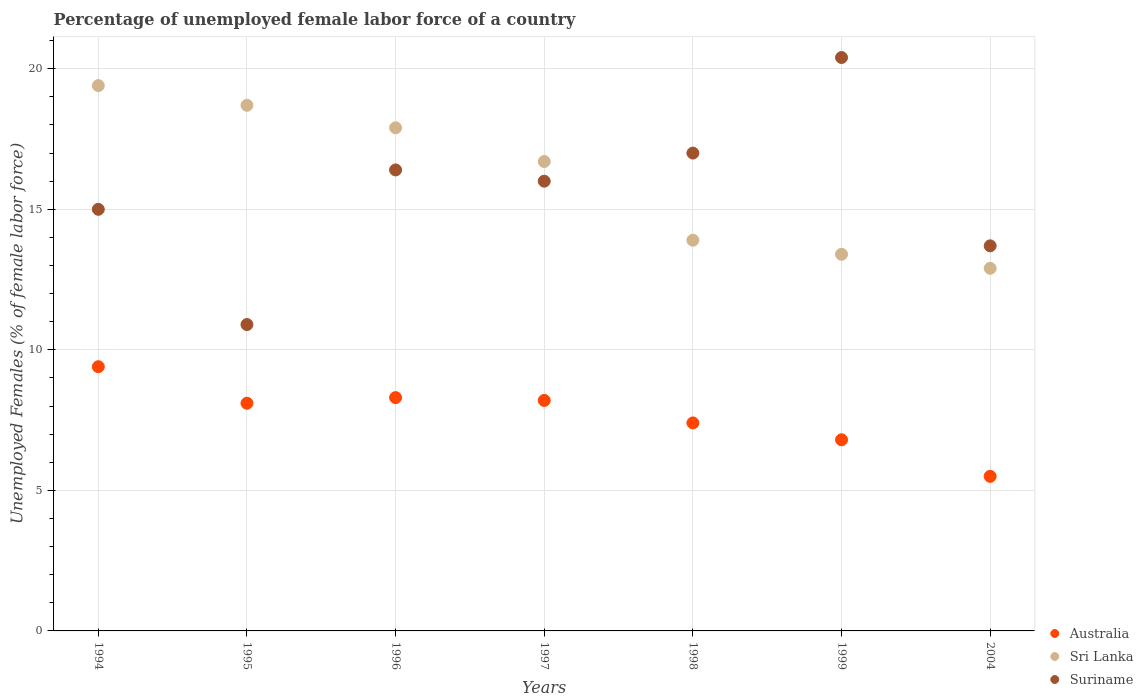How many different coloured dotlines are there?
Your answer should be compact. 3. Is the number of dotlines equal to the number of legend labels?
Offer a terse response. Yes. What is the percentage of unemployed female labor force in Suriname in 1995?
Provide a succinct answer. 10.9. Across all years, what is the maximum percentage of unemployed female labor force in Suriname?
Give a very brief answer. 20.4. Across all years, what is the minimum percentage of unemployed female labor force in Sri Lanka?
Provide a succinct answer. 12.9. In which year was the percentage of unemployed female labor force in Sri Lanka minimum?
Your response must be concise. 2004. What is the total percentage of unemployed female labor force in Sri Lanka in the graph?
Offer a very short reply. 112.9. What is the difference between the percentage of unemployed female labor force in Suriname in 1994 and that in 1995?
Ensure brevity in your answer.  4.1. What is the difference between the percentage of unemployed female labor force in Suriname in 1997 and the percentage of unemployed female labor force in Sri Lanka in 1996?
Your answer should be very brief. -1.9. What is the average percentage of unemployed female labor force in Suriname per year?
Offer a very short reply. 15.63. In the year 1998, what is the difference between the percentage of unemployed female labor force in Sri Lanka and percentage of unemployed female labor force in Suriname?
Your answer should be very brief. -3.1. What is the ratio of the percentage of unemployed female labor force in Sri Lanka in 1995 to that in 2004?
Your answer should be very brief. 1.45. Is the percentage of unemployed female labor force in Suriname in 1994 less than that in 1995?
Your answer should be compact. No. Is the difference between the percentage of unemployed female labor force in Sri Lanka in 1998 and 2004 greater than the difference between the percentage of unemployed female labor force in Suriname in 1998 and 2004?
Provide a short and direct response. No. What is the difference between the highest and the second highest percentage of unemployed female labor force in Australia?
Ensure brevity in your answer.  1.1. What is the difference between the highest and the lowest percentage of unemployed female labor force in Australia?
Offer a terse response. 3.9. In how many years, is the percentage of unemployed female labor force in Sri Lanka greater than the average percentage of unemployed female labor force in Sri Lanka taken over all years?
Your answer should be very brief. 4. Is the percentage of unemployed female labor force in Sri Lanka strictly greater than the percentage of unemployed female labor force in Australia over the years?
Give a very brief answer. Yes. Is the percentage of unemployed female labor force in Australia strictly less than the percentage of unemployed female labor force in Sri Lanka over the years?
Your answer should be compact. Yes. How many years are there in the graph?
Your answer should be very brief. 7. What is the difference between two consecutive major ticks on the Y-axis?
Provide a short and direct response. 5. Where does the legend appear in the graph?
Your response must be concise. Bottom right. How many legend labels are there?
Keep it short and to the point. 3. How are the legend labels stacked?
Offer a terse response. Vertical. What is the title of the graph?
Your answer should be compact. Percentage of unemployed female labor force of a country. Does "Barbados" appear as one of the legend labels in the graph?
Make the answer very short. No. What is the label or title of the X-axis?
Provide a short and direct response. Years. What is the label or title of the Y-axis?
Give a very brief answer. Unemployed Females (% of female labor force). What is the Unemployed Females (% of female labor force) of Australia in 1994?
Make the answer very short. 9.4. What is the Unemployed Females (% of female labor force) of Sri Lanka in 1994?
Make the answer very short. 19.4. What is the Unemployed Females (% of female labor force) in Australia in 1995?
Keep it short and to the point. 8.1. What is the Unemployed Females (% of female labor force) of Sri Lanka in 1995?
Your answer should be compact. 18.7. What is the Unemployed Females (% of female labor force) of Suriname in 1995?
Your response must be concise. 10.9. What is the Unemployed Females (% of female labor force) in Australia in 1996?
Keep it short and to the point. 8.3. What is the Unemployed Females (% of female labor force) in Sri Lanka in 1996?
Your answer should be very brief. 17.9. What is the Unemployed Females (% of female labor force) in Suriname in 1996?
Make the answer very short. 16.4. What is the Unemployed Females (% of female labor force) in Australia in 1997?
Provide a short and direct response. 8.2. What is the Unemployed Females (% of female labor force) in Sri Lanka in 1997?
Keep it short and to the point. 16.7. What is the Unemployed Females (% of female labor force) in Suriname in 1997?
Offer a very short reply. 16. What is the Unemployed Females (% of female labor force) in Australia in 1998?
Your response must be concise. 7.4. What is the Unemployed Females (% of female labor force) in Sri Lanka in 1998?
Your answer should be very brief. 13.9. What is the Unemployed Females (% of female labor force) of Suriname in 1998?
Your answer should be compact. 17. What is the Unemployed Females (% of female labor force) in Australia in 1999?
Keep it short and to the point. 6.8. What is the Unemployed Females (% of female labor force) in Sri Lanka in 1999?
Keep it short and to the point. 13.4. What is the Unemployed Females (% of female labor force) of Suriname in 1999?
Your answer should be very brief. 20.4. What is the Unemployed Females (% of female labor force) in Australia in 2004?
Offer a very short reply. 5.5. What is the Unemployed Females (% of female labor force) of Sri Lanka in 2004?
Offer a very short reply. 12.9. What is the Unemployed Females (% of female labor force) in Suriname in 2004?
Provide a short and direct response. 13.7. Across all years, what is the maximum Unemployed Females (% of female labor force) of Australia?
Your answer should be compact. 9.4. Across all years, what is the maximum Unemployed Females (% of female labor force) of Sri Lanka?
Give a very brief answer. 19.4. Across all years, what is the maximum Unemployed Females (% of female labor force) in Suriname?
Give a very brief answer. 20.4. Across all years, what is the minimum Unemployed Females (% of female labor force) in Australia?
Provide a succinct answer. 5.5. Across all years, what is the minimum Unemployed Females (% of female labor force) of Sri Lanka?
Keep it short and to the point. 12.9. Across all years, what is the minimum Unemployed Females (% of female labor force) of Suriname?
Provide a short and direct response. 10.9. What is the total Unemployed Females (% of female labor force) of Australia in the graph?
Provide a succinct answer. 53.7. What is the total Unemployed Females (% of female labor force) in Sri Lanka in the graph?
Ensure brevity in your answer.  112.9. What is the total Unemployed Females (% of female labor force) in Suriname in the graph?
Your response must be concise. 109.4. What is the difference between the Unemployed Females (% of female labor force) in Sri Lanka in 1994 and that in 1995?
Your response must be concise. 0.7. What is the difference between the Unemployed Females (% of female labor force) in Australia in 1994 and that in 1996?
Your answer should be very brief. 1.1. What is the difference between the Unemployed Females (% of female labor force) of Australia in 1994 and that in 1997?
Make the answer very short. 1.2. What is the difference between the Unemployed Females (% of female labor force) in Sri Lanka in 1994 and that in 1999?
Your response must be concise. 6. What is the difference between the Unemployed Females (% of female labor force) in Suriname in 1994 and that in 1999?
Offer a very short reply. -5.4. What is the difference between the Unemployed Females (% of female labor force) in Australia in 1994 and that in 2004?
Ensure brevity in your answer.  3.9. What is the difference between the Unemployed Females (% of female labor force) in Sri Lanka in 1994 and that in 2004?
Provide a succinct answer. 6.5. What is the difference between the Unemployed Females (% of female labor force) in Sri Lanka in 1995 and that in 1996?
Provide a short and direct response. 0.8. What is the difference between the Unemployed Females (% of female labor force) in Suriname in 1995 and that in 1996?
Provide a short and direct response. -5.5. What is the difference between the Unemployed Females (% of female labor force) in Australia in 1995 and that in 1997?
Provide a short and direct response. -0.1. What is the difference between the Unemployed Females (% of female labor force) in Sri Lanka in 1995 and that in 1997?
Make the answer very short. 2. What is the difference between the Unemployed Females (% of female labor force) of Suriname in 1995 and that in 1997?
Offer a very short reply. -5.1. What is the difference between the Unemployed Females (% of female labor force) of Australia in 1995 and that in 1998?
Your answer should be compact. 0.7. What is the difference between the Unemployed Females (% of female labor force) in Suriname in 1995 and that in 1998?
Ensure brevity in your answer.  -6.1. What is the difference between the Unemployed Females (% of female labor force) of Australia in 1995 and that in 1999?
Your response must be concise. 1.3. What is the difference between the Unemployed Females (% of female labor force) of Suriname in 1995 and that in 1999?
Ensure brevity in your answer.  -9.5. What is the difference between the Unemployed Females (% of female labor force) in Sri Lanka in 1996 and that in 1997?
Provide a short and direct response. 1.2. What is the difference between the Unemployed Females (% of female labor force) of Australia in 1996 and that in 1998?
Make the answer very short. 0.9. What is the difference between the Unemployed Females (% of female labor force) in Sri Lanka in 1996 and that in 1998?
Your answer should be very brief. 4. What is the difference between the Unemployed Females (% of female labor force) of Sri Lanka in 1996 and that in 1999?
Your answer should be very brief. 4.5. What is the difference between the Unemployed Females (% of female labor force) of Sri Lanka in 1996 and that in 2004?
Make the answer very short. 5. What is the difference between the Unemployed Females (% of female labor force) in Sri Lanka in 1997 and that in 1998?
Provide a succinct answer. 2.8. What is the difference between the Unemployed Females (% of female labor force) of Australia in 1997 and that in 1999?
Provide a short and direct response. 1.4. What is the difference between the Unemployed Females (% of female labor force) of Suriname in 1997 and that in 1999?
Keep it short and to the point. -4.4. What is the difference between the Unemployed Females (% of female labor force) in Suriname in 1997 and that in 2004?
Offer a very short reply. 2.3. What is the difference between the Unemployed Females (% of female labor force) of Sri Lanka in 1998 and that in 1999?
Your answer should be compact. 0.5. What is the difference between the Unemployed Females (% of female labor force) of Suriname in 1998 and that in 1999?
Your response must be concise. -3.4. What is the difference between the Unemployed Females (% of female labor force) of Suriname in 1998 and that in 2004?
Give a very brief answer. 3.3. What is the difference between the Unemployed Females (% of female labor force) of Australia in 1999 and that in 2004?
Give a very brief answer. 1.3. What is the difference between the Unemployed Females (% of female labor force) of Australia in 1994 and the Unemployed Females (% of female labor force) of Sri Lanka in 1995?
Ensure brevity in your answer.  -9.3. What is the difference between the Unemployed Females (% of female labor force) in Australia in 1994 and the Unemployed Females (% of female labor force) in Suriname in 1995?
Provide a short and direct response. -1.5. What is the difference between the Unemployed Females (% of female labor force) of Sri Lanka in 1994 and the Unemployed Females (% of female labor force) of Suriname in 1995?
Your answer should be compact. 8.5. What is the difference between the Unemployed Females (% of female labor force) in Sri Lanka in 1994 and the Unemployed Females (% of female labor force) in Suriname in 1996?
Provide a short and direct response. 3. What is the difference between the Unemployed Females (% of female labor force) in Sri Lanka in 1994 and the Unemployed Females (% of female labor force) in Suriname in 1997?
Your answer should be very brief. 3.4. What is the difference between the Unemployed Females (% of female labor force) of Australia in 1994 and the Unemployed Females (% of female labor force) of Sri Lanka in 1998?
Ensure brevity in your answer.  -4.5. What is the difference between the Unemployed Females (% of female labor force) of Australia in 1994 and the Unemployed Females (% of female labor force) of Suriname in 1998?
Your answer should be compact. -7.6. What is the difference between the Unemployed Females (% of female labor force) in Sri Lanka in 1994 and the Unemployed Females (% of female labor force) in Suriname in 1998?
Offer a very short reply. 2.4. What is the difference between the Unemployed Females (% of female labor force) of Sri Lanka in 1994 and the Unemployed Females (% of female labor force) of Suriname in 1999?
Offer a very short reply. -1. What is the difference between the Unemployed Females (% of female labor force) of Australia in 1995 and the Unemployed Females (% of female labor force) of Suriname in 1996?
Keep it short and to the point. -8.3. What is the difference between the Unemployed Females (% of female labor force) of Sri Lanka in 1995 and the Unemployed Females (% of female labor force) of Suriname in 1997?
Make the answer very short. 2.7. What is the difference between the Unemployed Females (% of female labor force) in Sri Lanka in 1995 and the Unemployed Females (% of female labor force) in Suriname in 1998?
Give a very brief answer. 1.7. What is the difference between the Unemployed Females (% of female labor force) of Sri Lanka in 1995 and the Unemployed Females (% of female labor force) of Suriname in 1999?
Offer a terse response. -1.7. What is the difference between the Unemployed Females (% of female labor force) of Australia in 1995 and the Unemployed Females (% of female labor force) of Suriname in 2004?
Offer a very short reply. -5.6. What is the difference between the Unemployed Females (% of female labor force) in Sri Lanka in 1995 and the Unemployed Females (% of female labor force) in Suriname in 2004?
Provide a short and direct response. 5. What is the difference between the Unemployed Females (% of female labor force) in Australia in 1996 and the Unemployed Females (% of female labor force) in Sri Lanka in 1997?
Provide a succinct answer. -8.4. What is the difference between the Unemployed Females (% of female labor force) in Australia in 1996 and the Unemployed Females (% of female labor force) in Suriname in 1997?
Give a very brief answer. -7.7. What is the difference between the Unemployed Females (% of female labor force) in Sri Lanka in 1996 and the Unemployed Females (% of female labor force) in Suriname in 1997?
Provide a succinct answer. 1.9. What is the difference between the Unemployed Females (% of female labor force) in Australia in 1996 and the Unemployed Females (% of female labor force) in Sri Lanka in 1998?
Provide a succinct answer. -5.6. What is the difference between the Unemployed Females (% of female labor force) in Australia in 1996 and the Unemployed Females (% of female labor force) in Suriname in 1998?
Ensure brevity in your answer.  -8.7. What is the difference between the Unemployed Females (% of female labor force) in Sri Lanka in 1996 and the Unemployed Females (% of female labor force) in Suriname in 1998?
Make the answer very short. 0.9. What is the difference between the Unemployed Females (% of female labor force) in Australia in 1996 and the Unemployed Females (% of female labor force) in Sri Lanka in 1999?
Ensure brevity in your answer.  -5.1. What is the difference between the Unemployed Females (% of female labor force) in Australia in 1996 and the Unemployed Females (% of female labor force) in Suriname in 1999?
Ensure brevity in your answer.  -12.1. What is the difference between the Unemployed Females (% of female labor force) in Australia in 1996 and the Unemployed Females (% of female labor force) in Sri Lanka in 2004?
Your answer should be compact. -4.6. What is the difference between the Unemployed Females (% of female labor force) in Australia in 1996 and the Unemployed Females (% of female labor force) in Suriname in 2004?
Provide a short and direct response. -5.4. What is the difference between the Unemployed Females (% of female labor force) in Sri Lanka in 1996 and the Unemployed Females (% of female labor force) in Suriname in 2004?
Provide a short and direct response. 4.2. What is the difference between the Unemployed Females (% of female labor force) in Australia in 1997 and the Unemployed Females (% of female labor force) in Sri Lanka in 1998?
Provide a short and direct response. -5.7. What is the difference between the Unemployed Females (% of female labor force) in Australia in 1997 and the Unemployed Females (% of female labor force) in Suriname in 1999?
Provide a short and direct response. -12.2. What is the difference between the Unemployed Females (% of female labor force) of Australia in 1997 and the Unemployed Females (% of female labor force) of Sri Lanka in 2004?
Provide a succinct answer. -4.7. What is the difference between the Unemployed Females (% of female labor force) in Australia in 1997 and the Unemployed Females (% of female labor force) in Suriname in 2004?
Provide a short and direct response. -5.5. What is the difference between the Unemployed Females (% of female labor force) in Sri Lanka in 1997 and the Unemployed Females (% of female labor force) in Suriname in 2004?
Provide a short and direct response. 3. What is the difference between the Unemployed Females (% of female labor force) in Australia in 1998 and the Unemployed Females (% of female labor force) in Sri Lanka in 1999?
Your answer should be compact. -6. What is the difference between the Unemployed Females (% of female labor force) of Australia in 1998 and the Unemployed Females (% of female labor force) of Suriname in 1999?
Make the answer very short. -13. What is the difference between the Unemployed Females (% of female labor force) of Australia in 1998 and the Unemployed Females (% of female labor force) of Suriname in 2004?
Provide a succinct answer. -6.3. What is the average Unemployed Females (% of female labor force) of Australia per year?
Offer a terse response. 7.67. What is the average Unemployed Females (% of female labor force) of Sri Lanka per year?
Ensure brevity in your answer.  16.13. What is the average Unemployed Females (% of female labor force) of Suriname per year?
Give a very brief answer. 15.63. In the year 1994, what is the difference between the Unemployed Females (% of female labor force) in Australia and Unemployed Females (% of female labor force) in Sri Lanka?
Provide a short and direct response. -10. In the year 1994, what is the difference between the Unemployed Females (% of female labor force) in Sri Lanka and Unemployed Females (% of female labor force) in Suriname?
Offer a terse response. 4.4. In the year 1996, what is the difference between the Unemployed Females (% of female labor force) in Australia and Unemployed Females (% of female labor force) in Suriname?
Provide a short and direct response. -8.1. In the year 1997, what is the difference between the Unemployed Females (% of female labor force) in Australia and Unemployed Females (% of female labor force) in Sri Lanka?
Make the answer very short. -8.5. In the year 1998, what is the difference between the Unemployed Females (% of female labor force) in Australia and Unemployed Females (% of female labor force) in Sri Lanka?
Your answer should be compact. -6.5. In the year 1998, what is the difference between the Unemployed Females (% of female labor force) of Australia and Unemployed Females (% of female labor force) of Suriname?
Ensure brevity in your answer.  -9.6. In the year 1998, what is the difference between the Unemployed Females (% of female labor force) in Sri Lanka and Unemployed Females (% of female labor force) in Suriname?
Give a very brief answer. -3.1. In the year 2004, what is the difference between the Unemployed Females (% of female labor force) of Australia and Unemployed Females (% of female labor force) of Sri Lanka?
Keep it short and to the point. -7.4. In the year 2004, what is the difference between the Unemployed Females (% of female labor force) in Australia and Unemployed Females (% of female labor force) in Suriname?
Offer a very short reply. -8.2. In the year 2004, what is the difference between the Unemployed Females (% of female labor force) in Sri Lanka and Unemployed Females (% of female labor force) in Suriname?
Your response must be concise. -0.8. What is the ratio of the Unemployed Females (% of female labor force) of Australia in 1994 to that in 1995?
Provide a short and direct response. 1.16. What is the ratio of the Unemployed Females (% of female labor force) of Sri Lanka in 1994 to that in 1995?
Your answer should be compact. 1.04. What is the ratio of the Unemployed Females (% of female labor force) of Suriname in 1994 to that in 1995?
Ensure brevity in your answer.  1.38. What is the ratio of the Unemployed Females (% of female labor force) in Australia in 1994 to that in 1996?
Offer a very short reply. 1.13. What is the ratio of the Unemployed Females (% of female labor force) of Sri Lanka in 1994 to that in 1996?
Your response must be concise. 1.08. What is the ratio of the Unemployed Females (% of female labor force) of Suriname in 1994 to that in 1996?
Your answer should be compact. 0.91. What is the ratio of the Unemployed Females (% of female labor force) of Australia in 1994 to that in 1997?
Your answer should be very brief. 1.15. What is the ratio of the Unemployed Females (% of female labor force) of Sri Lanka in 1994 to that in 1997?
Your answer should be very brief. 1.16. What is the ratio of the Unemployed Females (% of female labor force) in Australia in 1994 to that in 1998?
Your answer should be compact. 1.27. What is the ratio of the Unemployed Females (% of female labor force) of Sri Lanka in 1994 to that in 1998?
Your response must be concise. 1.4. What is the ratio of the Unemployed Females (% of female labor force) of Suriname in 1994 to that in 1998?
Give a very brief answer. 0.88. What is the ratio of the Unemployed Females (% of female labor force) in Australia in 1994 to that in 1999?
Keep it short and to the point. 1.38. What is the ratio of the Unemployed Females (% of female labor force) in Sri Lanka in 1994 to that in 1999?
Give a very brief answer. 1.45. What is the ratio of the Unemployed Females (% of female labor force) in Suriname in 1994 to that in 1999?
Your answer should be compact. 0.74. What is the ratio of the Unemployed Females (% of female labor force) in Australia in 1994 to that in 2004?
Ensure brevity in your answer.  1.71. What is the ratio of the Unemployed Females (% of female labor force) in Sri Lanka in 1994 to that in 2004?
Your answer should be very brief. 1.5. What is the ratio of the Unemployed Females (% of female labor force) of Suriname in 1994 to that in 2004?
Offer a very short reply. 1.09. What is the ratio of the Unemployed Females (% of female labor force) in Australia in 1995 to that in 1996?
Offer a very short reply. 0.98. What is the ratio of the Unemployed Females (% of female labor force) in Sri Lanka in 1995 to that in 1996?
Offer a terse response. 1.04. What is the ratio of the Unemployed Females (% of female labor force) of Suriname in 1995 to that in 1996?
Make the answer very short. 0.66. What is the ratio of the Unemployed Females (% of female labor force) in Sri Lanka in 1995 to that in 1997?
Your response must be concise. 1.12. What is the ratio of the Unemployed Females (% of female labor force) in Suriname in 1995 to that in 1997?
Your answer should be compact. 0.68. What is the ratio of the Unemployed Females (% of female labor force) of Australia in 1995 to that in 1998?
Ensure brevity in your answer.  1.09. What is the ratio of the Unemployed Females (% of female labor force) of Sri Lanka in 1995 to that in 1998?
Give a very brief answer. 1.35. What is the ratio of the Unemployed Females (% of female labor force) in Suriname in 1995 to that in 1998?
Make the answer very short. 0.64. What is the ratio of the Unemployed Females (% of female labor force) of Australia in 1995 to that in 1999?
Keep it short and to the point. 1.19. What is the ratio of the Unemployed Females (% of female labor force) of Sri Lanka in 1995 to that in 1999?
Give a very brief answer. 1.4. What is the ratio of the Unemployed Females (% of female labor force) in Suriname in 1995 to that in 1999?
Provide a succinct answer. 0.53. What is the ratio of the Unemployed Females (% of female labor force) in Australia in 1995 to that in 2004?
Your answer should be compact. 1.47. What is the ratio of the Unemployed Females (% of female labor force) of Sri Lanka in 1995 to that in 2004?
Give a very brief answer. 1.45. What is the ratio of the Unemployed Females (% of female labor force) in Suriname in 1995 to that in 2004?
Ensure brevity in your answer.  0.8. What is the ratio of the Unemployed Females (% of female labor force) in Australia in 1996 to that in 1997?
Make the answer very short. 1.01. What is the ratio of the Unemployed Females (% of female labor force) in Sri Lanka in 1996 to that in 1997?
Keep it short and to the point. 1.07. What is the ratio of the Unemployed Females (% of female labor force) in Suriname in 1996 to that in 1997?
Your answer should be compact. 1.02. What is the ratio of the Unemployed Females (% of female labor force) of Australia in 1996 to that in 1998?
Your answer should be very brief. 1.12. What is the ratio of the Unemployed Females (% of female labor force) of Sri Lanka in 1996 to that in 1998?
Make the answer very short. 1.29. What is the ratio of the Unemployed Females (% of female labor force) of Suriname in 1996 to that in 1998?
Offer a very short reply. 0.96. What is the ratio of the Unemployed Females (% of female labor force) in Australia in 1996 to that in 1999?
Provide a succinct answer. 1.22. What is the ratio of the Unemployed Females (% of female labor force) in Sri Lanka in 1996 to that in 1999?
Give a very brief answer. 1.34. What is the ratio of the Unemployed Females (% of female labor force) of Suriname in 1996 to that in 1999?
Provide a succinct answer. 0.8. What is the ratio of the Unemployed Females (% of female labor force) in Australia in 1996 to that in 2004?
Offer a terse response. 1.51. What is the ratio of the Unemployed Females (% of female labor force) of Sri Lanka in 1996 to that in 2004?
Provide a short and direct response. 1.39. What is the ratio of the Unemployed Females (% of female labor force) in Suriname in 1996 to that in 2004?
Provide a short and direct response. 1.2. What is the ratio of the Unemployed Females (% of female labor force) of Australia in 1997 to that in 1998?
Your answer should be compact. 1.11. What is the ratio of the Unemployed Females (% of female labor force) of Sri Lanka in 1997 to that in 1998?
Offer a very short reply. 1.2. What is the ratio of the Unemployed Females (% of female labor force) in Australia in 1997 to that in 1999?
Offer a very short reply. 1.21. What is the ratio of the Unemployed Females (% of female labor force) of Sri Lanka in 1997 to that in 1999?
Offer a very short reply. 1.25. What is the ratio of the Unemployed Females (% of female labor force) of Suriname in 1997 to that in 1999?
Provide a succinct answer. 0.78. What is the ratio of the Unemployed Females (% of female labor force) in Australia in 1997 to that in 2004?
Your answer should be compact. 1.49. What is the ratio of the Unemployed Females (% of female labor force) of Sri Lanka in 1997 to that in 2004?
Offer a very short reply. 1.29. What is the ratio of the Unemployed Females (% of female labor force) of Suriname in 1997 to that in 2004?
Your response must be concise. 1.17. What is the ratio of the Unemployed Females (% of female labor force) in Australia in 1998 to that in 1999?
Keep it short and to the point. 1.09. What is the ratio of the Unemployed Females (% of female labor force) of Sri Lanka in 1998 to that in 1999?
Offer a very short reply. 1.04. What is the ratio of the Unemployed Females (% of female labor force) of Australia in 1998 to that in 2004?
Offer a terse response. 1.35. What is the ratio of the Unemployed Females (% of female labor force) of Sri Lanka in 1998 to that in 2004?
Keep it short and to the point. 1.08. What is the ratio of the Unemployed Females (% of female labor force) of Suriname in 1998 to that in 2004?
Ensure brevity in your answer.  1.24. What is the ratio of the Unemployed Females (% of female labor force) in Australia in 1999 to that in 2004?
Keep it short and to the point. 1.24. What is the ratio of the Unemployed Females (% of female labor force) in Sri Lanka in 1999 to that in 2004?
Your response must be concise. 1.04. What is the ratio of the Unemployed Females (% of female labor force) of Suriname in 1999 to that in 2004?
Offer a terse response. 1.49. What is the difference between the highest and the second highest Unemployed Females (% of female labor force) of Australia?
Offer a very short reply. 1.1. What is the difference between the highest and the lowest Unemployed Females (% of female labor force) of Australia?
Your response must be concise. 3.9. What is the difference between the highest and the lowest Unemployed Females (% of female labor force) of Sri Lanka?
Your answer should be very brief. 6.5. 